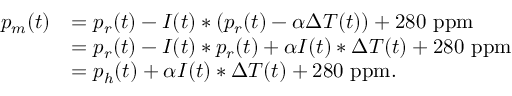<formula> <loc_0><loc_0><loc_500><loc_500>\begin{array} { r l } { p _ { m } ( t ) } & { = p _ { r } ( t ) - I ( t ) \ast ( p _ { r } ( t ) - \alpha \Delta T ( t ) ) + 2 8 0 p p m } \\ & { = p _ { r } ( t ) - I ( t ) \ast p _ { r } ( t ) + \alpha I ( t ) \ast \Delta T ( t ) + 2 8 0 p p m } \\ & { = p _ { h } ( t ) + \alpha I ( t ) \ast \Delta T ( t ) + 2 8 0 p p m . } \end{array}</formula> 